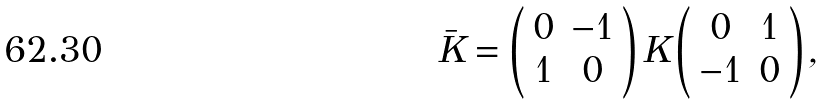<formula> <loc_0><loc_0><loc_500><loc_500>\bar { K } = \left ( \begin{array} { c c } 0 & - 1 \\ 1 & 0 \\ \end{array} \right ) K \left ( \begin{array} { c c } 0 & 1 \\ - 1 & 0 \\ \end{array} \right ) ,</formula> 